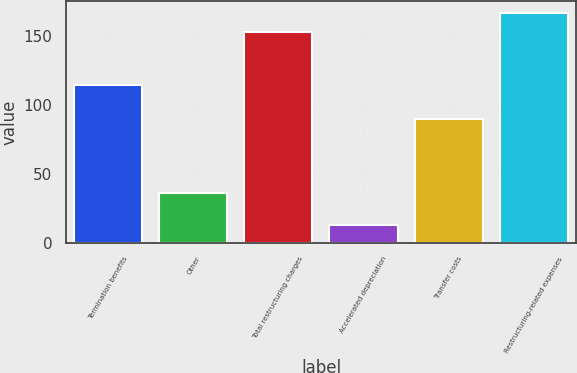Convert chart. <chart><loc_0><loc_0><loc_500><loc_500><bar_chart><fcel>Termination benefits<fcel>Other<fcel>Total restructuring charges<fcel>Accelerated depreciation<fcel>Transfer costs<fcel>Restructuring-related expenses<nl><fcel>115<fcel>36<fcel>153<fcel>13<fcel>90<fcel>167.2<nl></chart> 